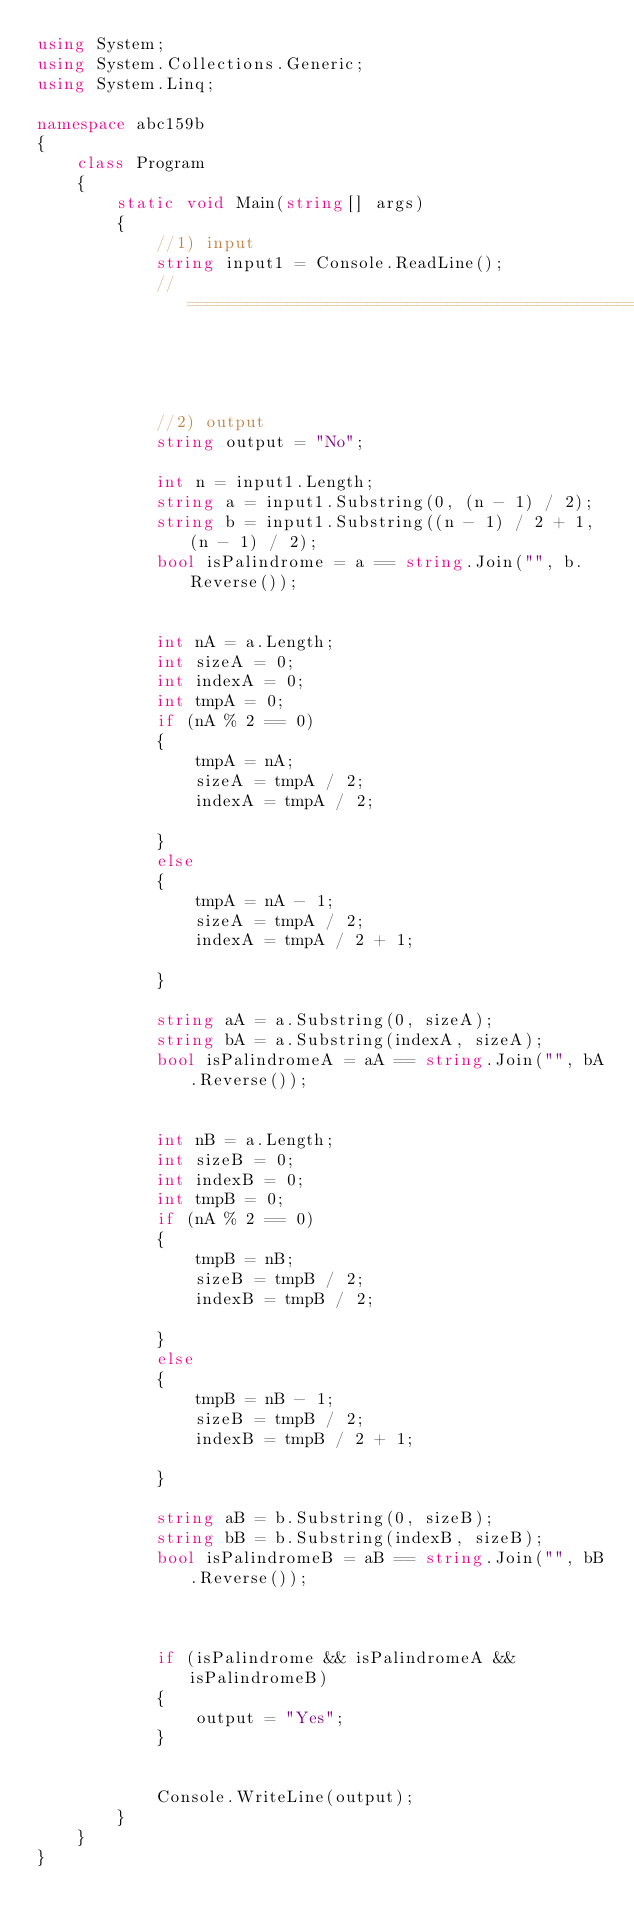Convert code to text. <code><loc_0><loc_0><loc_500><loc_500><_C#_>using System;
using System.Collections.Generic;
using System.Linq;

namespace abc159b
{
    class Program
    {
        static void Main(string[] args)
        {
            //1) input
            string input1 = Console.ReadLine();
            //==========================================================================================================================




            //2) output
            string output = "No";

            int n = input1.Length;
            string a = input1.Substring(0, (n - 1) / 2);
            string b = input1.Substring((n - 1) / 2 + 1, (n - 1) / 2);
            bool isPalindrome = a == string.Join("", b.Reverse());


            int nA = a.Length;
            int sizeA = 0;
            int indexA = 0;
            int tmpA = 0;
            if (nA % 2 == 0)
            {
                tmpA = nA;
                sizeA = tmpA / 2;
                indexA = tmpA / 2;

            }
            else
            {
                tmpA = nA - 1;
                sizeA = tmpA / 2;
                indexA = tmpA / 2 + 1;

            }

            string aA = a.Substring(0, sizeA);           
            string bA = a.Substring(indexA, sizeA);
            bool isPalindromeA = aA == string.Join("", bA.Reverse());


            int nB = a.Length;
            int sizeB = 0;
            int indexB = 0;
            int tmpB = 0;
            if (nA % 2 == 0)
            {
                tmpB = nB;
                sizeB = tmpB / 2;
                indexB = tmpB / 2;

            }
            else
            {
                tmpB = nB - 1;
                sizeB = tmpB / 2;
                indexB = tmpB / 2 + 1;

            }

            string aB = b.Substring(0, sizeB);
            string bB = b.Substring(indexB, sizeB);
            bool isPalindromeB = aB == string.Join("", bB.Reverse());



            if (isPalindrome && isPalindromeA && isPalindromeB)
            {
                output = "Yes";
            }


            Console.WriteLine(output);
        }
    }
}
</code> 